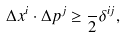<formula> <loc_0><loc_0><loc_500><loc_500>\Delta x ^ { i } \cdot \Delta p ^ { j } \geq \frac { } { 2 } \delta ^ { i j } ,</formula> 